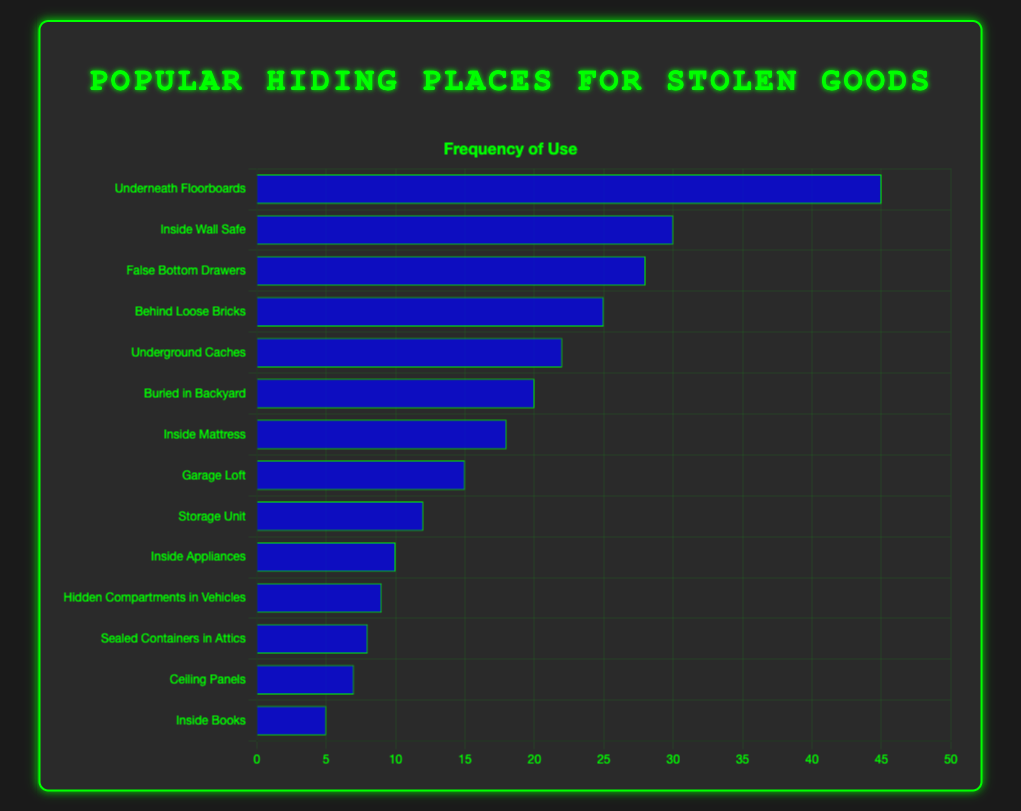What is the hiding place with the highest frequency? The bar representing "Underneath Floorboards" is the tallest, indicating it has the highest frequency among all hiding places.
Answer: Underneath Floorboards Which two hiding places have the closest frequencies? By visually comparing the heights of the bars, "Buried in Backyard" (frequency 20) and "Inside Mattress" (frequency 18) are the closest in height.
Answer: Buried in Backyard and Inside Mattress How much more frequent is "Underneath Floorboards" compared to "Inside Wall Safe"? "Underneath Floorboards" has a frequency of 45 and "Inside Wall Safe" has a frequency of 30. Subtracting 30 from 45 gives the difference.
Answer: 15 Which hiding place has the lowest frequency? The shortest bar represents "Inside Books" with a frequency of 5.
Answer: Inside Books What is the combined frequency of "Behind Loose Bricks" and "Underground Caches"? The frequencies of "Behind Loose Bricks" (25) and "Underground Caches" (22) add up to 25 + 22.
Answer: 47 Are there more hiding places with frequencies above or below 20? Identifying hiding places with frequencies above 20: "Underneath Floorboards", "Inside Wall Safe", "False Bottom Drawers", "Behind Loose Bricks", "Underground Caches", and "Buried in Backyard" give 6. Hiding places below 20: "Inside Mattress", "Garage Loft", "Storage Unit", "Inside Appliances", "Hidden Compartments in Vehicles", "Sealed Containers in Attics", "Ceiling Panels", "Inside Books" give 8.
Answer: Below What is the average frequency of all hiding places? Sum all frequencies (45 + 30 + 28 + 25 + 22 + 20 + 18 + 15 + 12 + 10 + 9 + 8 + 7 + 5 = 254) and divide by the number of hiding places (14). 254 / 14 = 18.14
Answer: 18.14 Which hiding place has a frequency closest to the average frequency? The average frequency is 18.14. "Inside Mattress" has a frequency of 18, which is closest to 18.14.
Answer: Inside Mattress How many hiding places have a frequency of at least 25? Bars representing "Underneath Floorboards", "Inside Wall Safe", "False Bottom Drawers", and "Behind Loose Bricks" have frequencies of 25 or higher.
Answer: 4 